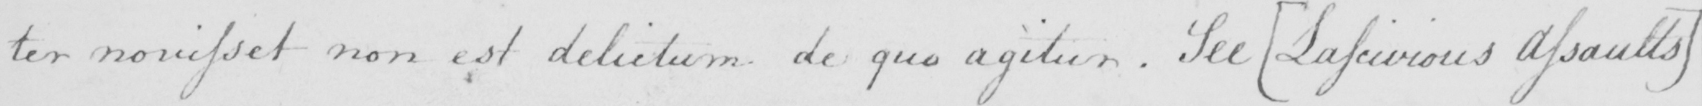Please transcribe the handwritten text in this image. : ter nouisset non est delictum de quo agitur . See  [ Lascivious Assaults ] 